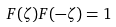Convert formula to latex. <formula><loc_0><loc_0><loc_500><loc_500>F ( \zeta ) F ( - \zeta ) = 1</formula> 